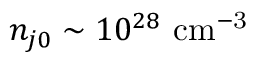Convert formula to latex. <formula><loc_0><loc_0><loc_500><loc_500>n _ { j 0 } \sim 1 0 ^ { 2 8 } { c m } ^ { - 3 }</formula> 